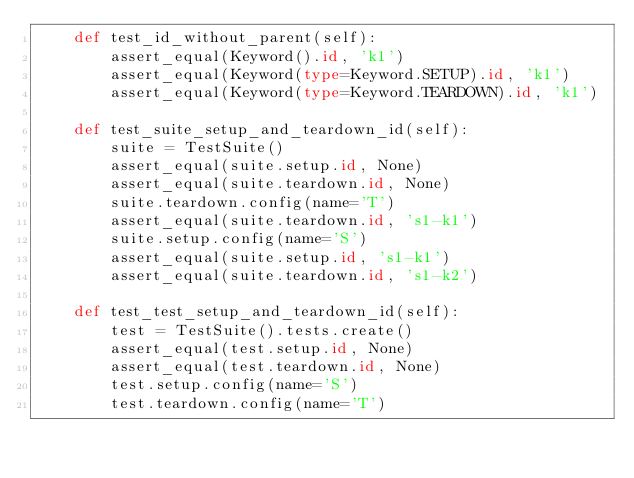<code> <loc_0><loc_0><loc_500><loc_500><_Python_>    def test_id_without_parent(self):
        assert_equal(Keyword().id, 'k1')
        assert_equal(Keyword(type=Keyword.SETUP).id, 'k1')
        assert_equal(Keyword(type=Keyword.TEARDOWN).id, 'k1')

    def test_suite_setup_and_teardown_id(self):
        suite = TestSuite()
        assert_equal(suite.setup.id, None)
        assert_equal(suite.teardown.id, None)
        suite.teardown.config(name='T')
        assert_equal(suite.teardown.id, 's1-k1')
        suite.setup.config(name='S')
        assert_equal(suite.setup.id, 's1-k1')
        assert_equal(suite.teardown.id, 's1-k2')

    def test_test_setup_and_teardown_id(self):
        test = TestSuite().tests.create()
        assert_equal(test.setup.id, None)
        assert_equal(test.teardown.id, None)
        test.setup.config(name='S')
        test.teardown.config(name='T')</code> 